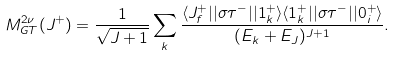<formula> <loc_0><loc_0><loc_500><loc_500>M ^ { 2 \nu } _ { G T } ( J ^ { + } ) = \frac { 1 } { \sqrt { J + 1 } } \sum _ { k } \frac { \langle J ^ { + } _ { f } | | \sigma \tau ^ { - } | | 1 ^ { + } _ { k } \rangle \langle 1 ^ { + } _ { k } | | \sigma \tau ^ { - } | | 0 ^ { + } _ { i } \rangle } { ( E _ { k } + E _ { J } ) ^ { J + 1 } } .</formula> 